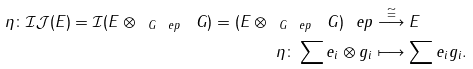Convert formula to latex. <formula><loc_0><loc_0><loc_500><loc_500>\eta \colon \mathcal { I J } ( E ) = \mathcal { I } ( E \otimes _ { \ G _ { \ } e p } \ G ) = ( E \otimes _ { \ G _ { \ } e p } \ G ) _ { \ } e p & \overset { \cong } { \longrightarrow } E \\ \eta \colon \sum e _ { i } \otimes g _ { i } & \longmapsto \sum e _ { i } g _ { i } .</formula> 